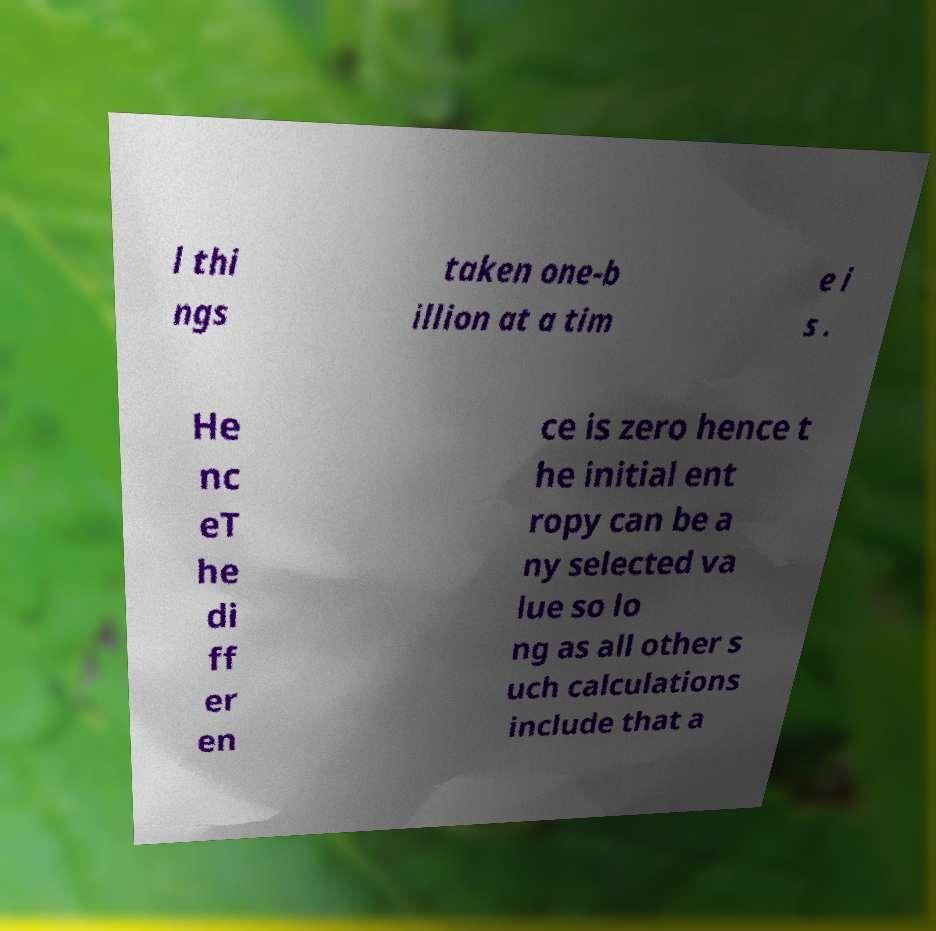Can you accurately transcribe the text from the provided image for me? l thi ngs taken one-b illion at a tim e i s . He nc eT he di ff er en ce is zero hence t he initial ent ropy can be a ny selected va lue so lo ng as all other s uch calculations include that a 